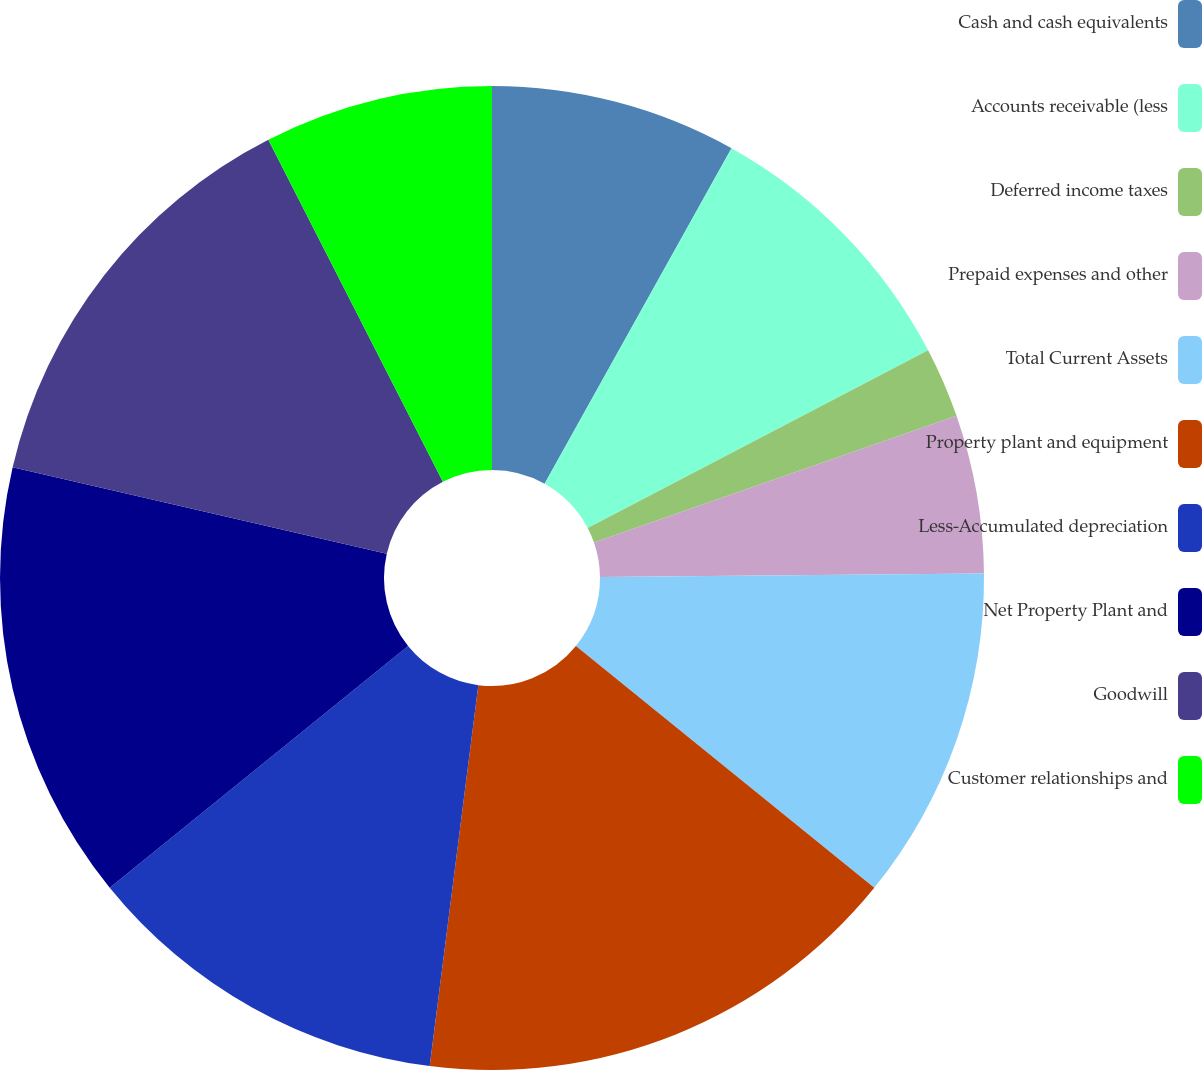Convert chart. <chart><loc_0><loc_0><loc_500><loc_500><pie_chart><fcel>Cash and cash equivalents<fcel>Accounts receivable (less<fcel>Deferred income taxes<fcel>Prepaid expenses and other<fcel>Total Current Assets<fcel>Property plant and equipment<fcel>Less-Accumulated depreciation<fcel>Net Property Plant and<fcel>Goodwill<fcel>Customer relationships and<nl><fcel>8.09%<fcel>9.25%<fcel>2.31%<fcel>5.2%<fcel>10.98%<fcel>16.18%<fcel>12.14%<fcel>14.45%<fcel>13.87%<fcel>7.51%<nl></chart> 